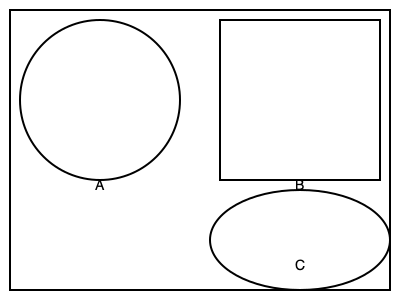As a server, you're tasked with plating a 6 oz portion of mashed potatoes. Which plate shape would make the portion appear the largest to customers? To determine which plate shape would make a 6 oz portion of mashed potatoes appear largest, we need to consider how the same volume of food would spread on different plate shapes:

1. Plate A (circular): The circular shape distributes food evenly, creating a moderate visual impact.

2. Plate B (square): The square shape has corners that may remain empty, concentrating the food in the center and potentially making it appear smaller.

3. Plate C (oval): The oval shape allows the food to spread out more along its length, creating an illusion of a larger portion.

The apparent size of the portion is influenced by how spread out it appears on the plate. The more surface area the food covers, the larger it will seem to the customer.

The oval plate (C) provides the best opportunity to spread the mashed potatoes out, creating a thinner layer that covers more visual area. This makes the portion appear larger than it would on the circular or square plates.

In culinary presentation, this principle is often used to create the illusion of generous portions while maintaining controlled serving sizes.
Answer: Plate C (oval) 